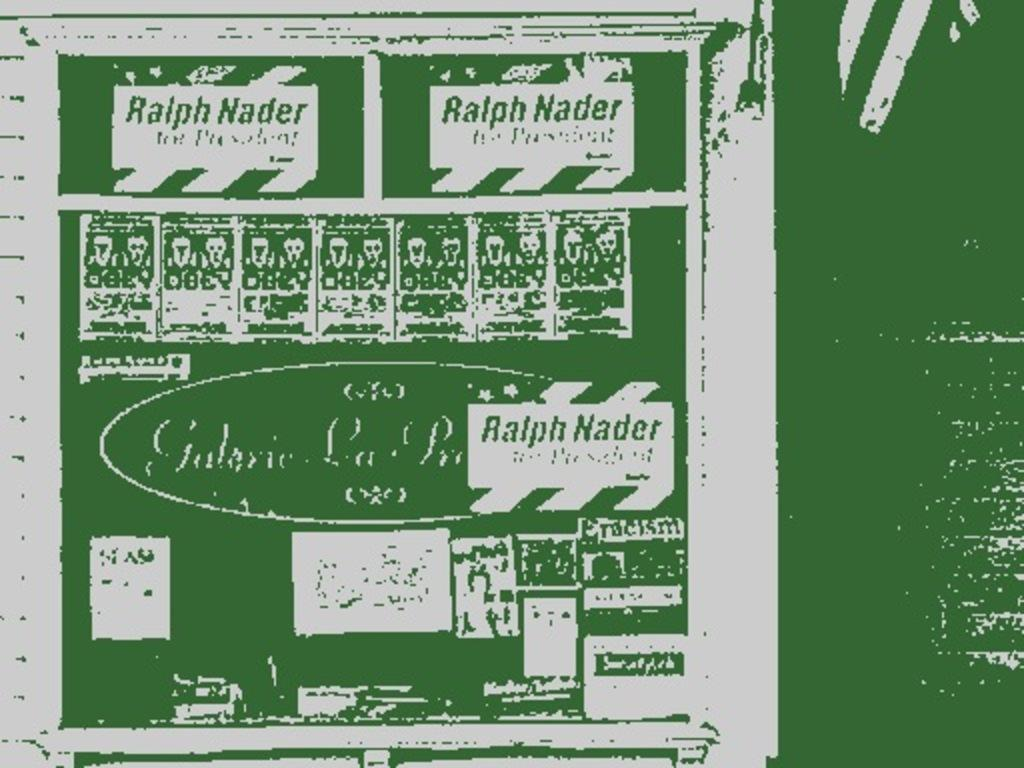<image>
Present a compact description of the photo's key features. Piece of paper with the name Ralph Nader wrote all on it 